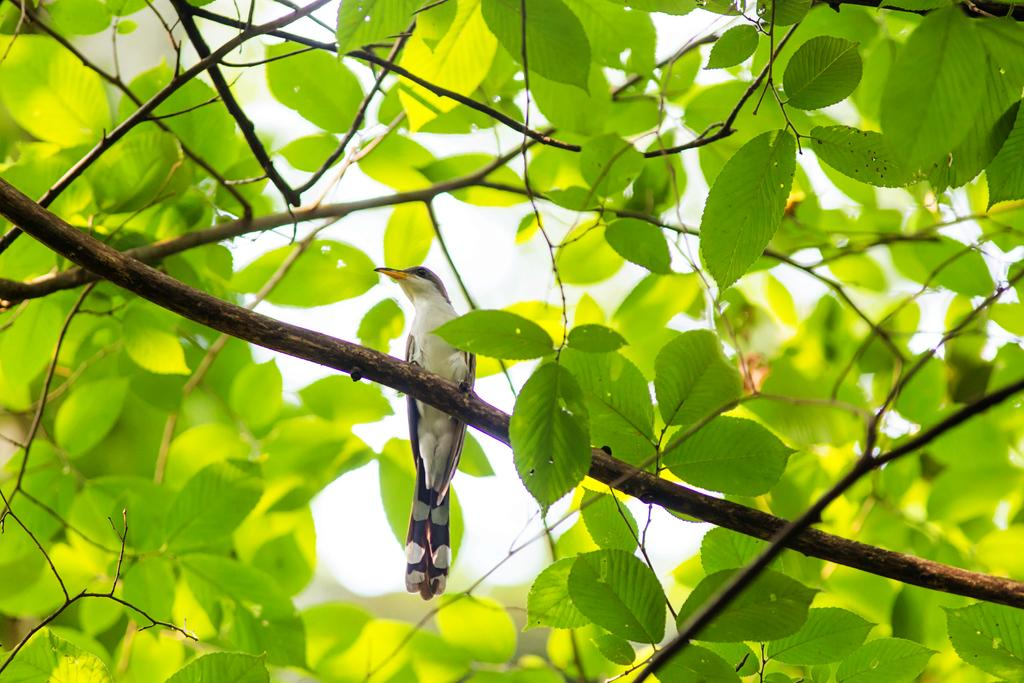What type of animal is in the image? There is a bird in the image. What is the bird standing on? The bird is standing on a branch. What can be seen in the background of the image? There are leaves visible in the image. What might the image depict? The image likely depicts a tree. What letter can be seen on the bird's wing in the image? There is no letter visible on the bird's wing in the image. Are there any beetles crawling on the leaves in the image? There is no mention of beetles in the provided facts, and therefore no such creatures can be observed in the image. 